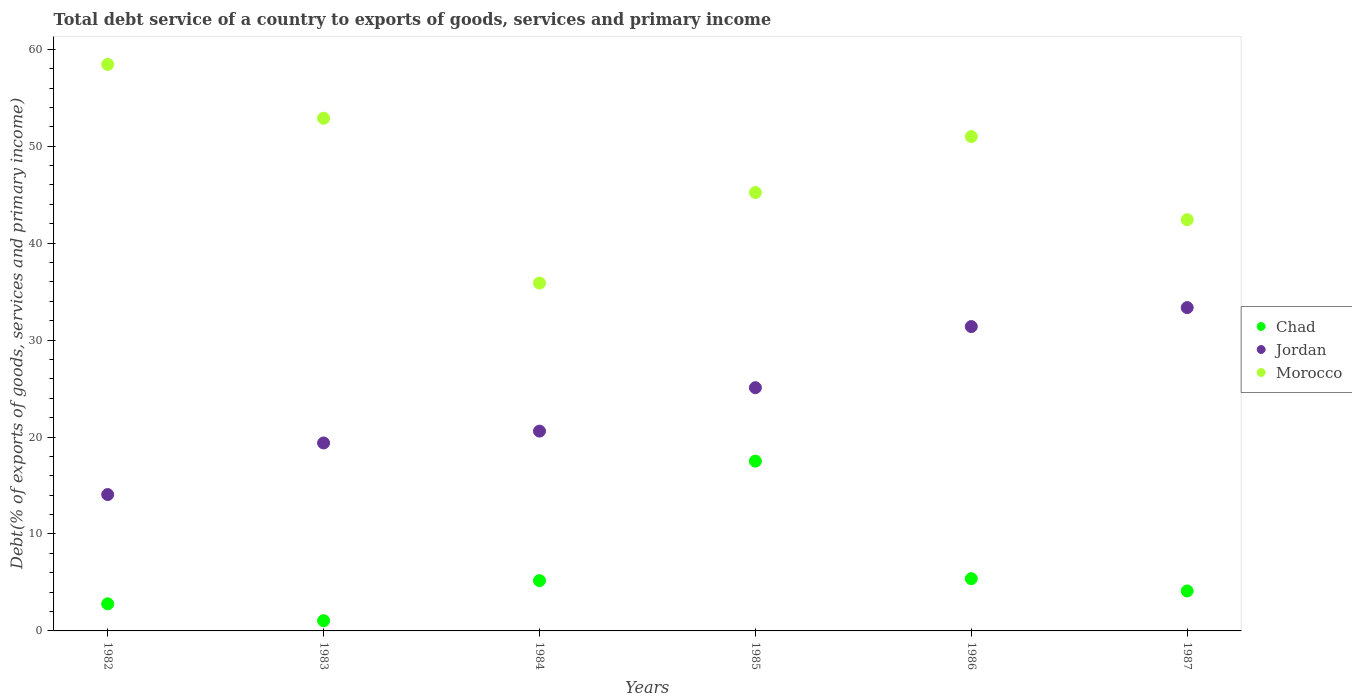How many different coloured dotlines are there?
Your answer should be very brief. 3. What is the total debt service in Morocco in 1983?
Your answer should be very brief. 52.88. Across all years, what is the maximum total debt service in Jordan?
Ensure brevity in your answer.  33.35. Across all years, what is the minimum total debt service in Jordan?
Ensure brevity in your answer.  14.07. What is the total total debt service in Jordan in the graph?
Your answer should be very brief. 143.9. What is the difference between the total debt service in Morocco in 1982 and that in 1987?
Offer a terse response. 16.02. What is the difference between the total debt service in Chad in 1984 and the total debt service in Morocco in 1982?
Offer a very short reply. -53.25. What is the average total debt service in Morocco per year?
Provide a succinct answer. 47.64. In the year 1987, what is the difference between the total debt service in Morocco and total debt service in Chad?
Keep it short and to the point. 38.3. In how many years, is the total debt service in Jordan greater than 26 %?
Give a very brief answer. 2. What is the ratio of the total debt service in Chad in 1982 to that in 1986?
Your answer should be very brief. 0.52. What is the difference between the highest and the second highest total debt service in Jordan?
Make the answer very short. 1.96. What is the difference between the highest and the lowest total debt service in Chad?
Your answer should be very brief. 16.46. In how many years, is the total debt service in Morocco greater than the average total debt service in Morocco taken over all years?
Provide a short and direct response. 3. Is the sum of the total debt service in Jordan in 1983 and 1987 greater than the maximum total debt service in Chad across all years?
Your answer should be compact. Yes. Is it the case that in every year, the sum of the total debt service in Morocco and total debt service in Jordan  is greater than the total debt service in Chad?
Give a very brief answer. Yes. Does the total debt service in Morocco monotonically increase over the years?
Give a very brief answer. No. Are the values on the major ticks of Y-axis written in scientific E-notation?
Offer a terse response. No. Does the graph contain any zero values?
Make the answer very short. No. Where does the legend appear in the graph?
Keep it short and to the point. Center right. How many legend labels are there?
Offer a terse response. 3. What is the title of the graph?
Your answer should be compact. Total debt service of a country to exports of goods, services and primary income. What is the label or title of the Y-axis?
Provide a short and direct response. Debt(% of exports of goods, services and primary income). What is the Debt(% of exports of goods, services and primary income) in Chad in 1982?
Your response must be concise. 2.8. What is the Debt(% of exports of goods, services and primary income) of Jordan in 1982?
Provide a short and direct response. 14.07. What is the Debt(% of exports of goods, services and primary income) of Morocco in 1982?
Offer a terse response. 58.44. What is the Debt(% of exports of goods, services and primary income) of Chad in 1983?
Your answer should be compact. 1.05. What is the Debt(% of exports of goods, services and primary income) in Jordan in 1983?
Provide a short and direct response. 19.39. What is the Debt(% of exports of goods, services and primary income) of Morocco in 1983?
Your response must be concise. 52.88. What is the Debt(% of exports of goods, services and primary income) of Chad in 1984?
Offer a very short reply. 5.19. What is the Debt(% of exports of goods, services and primary income) in Jordan in 1984?
Give a very brief answer. 20.61. What is the Debt(% of exports of goods, services and primary income) in Morocco in 1984?
Your response must be concise. 35.88. What is the Debt(% of exports of goods, services and primary income) of Chad in 1985?
Keep it short and to the point. 17.52. What is the Debt(% of exports of goods, services and primary income) in Jordan in 1985?
Your answer should be very brief. 25.09. What is the Debt(% of exports of goods, services and primary income) of Morocco in 1985?
Keep it short and to the point. 45.22. What is the Debt(% of exports of goods, services and primary income) in Chad in 1986?
Your response must be concise. 5.39. What is the Debt(% of exports of goods, services and primary income) of Jordan in 1986?
Your answer should be compact. 31.39. What is the Debt(% of exports of goods, services and primary income) in Morocco in 1986?
Offer a very short reply. 51. What is the Debt(% of exports of goods, services and primary income) in Chad in 1987?
Your answer should be very brief. 4.12. What is the Debt(% of exports of goods, services and primary income) in Jordan in 1987?
Keep it short and to the point. 33.35. What is the Debt(% of exports of goods, services and primary income) in Morocco in 1987?
Keep it short and to the point. 42.42. Across all years, what is the maximum Debt(% of exports of goods, services and primary income) of Chad?
Ensure brevity in your answer.  17.52. Across all years, what is the maximum Debt(% of exports of goods, services and primary income) in Jordan?
Your answer should be very brief. 33.35. Across all years, what is the maximum Debt(% of exports of goods, services and primary income) of Morocco?
Make the answer very short. 58.44. Across all years, what is the minimum Debt(% of exports of goods, services and primary income) of Chad?
Your answer should be compact. 1.05. Across all years, what is the minimum Debt(% of exports of goods, services and primary income) of Jordan?
Provide a succinct answer. 14.07. Across all years, what is the minimum Debt(% of exports of goods, services and primary income) of Morocco?
Ensure brevity in your answer.  35.88. What is the total Debt(% of exports of goods, services and primary income) in Chad in the graph?
Provide a short and direct response. 36.06. What is the total Debt(% of exports of goods, services and primary income) in Jordan in the graph?
Ensure brevity in your answer.  143.9. What is the total Debt(% of exports of goods, services and primary income) of Morocco in the graph?
Give a very brief answer. 285.85. What is the difference between the Debt(% of exports of goods, services and primary income) of Chad in 1982 and that in 1983?
Provide a short and direct response. 1.74. What is the difference between the Debt(% of exports of goods, services and primary income) in Jordan in 1982 and that in 1983?
Provide a succinct answer. -5.32. What is the difference between the Debt(% of exports of goods, services and primary income) of Morocco in 1982 and that in 1983?
Your answer should be very brief. 5.55. What is the difference between the Debt(% of exports of goods, services and primary income) of Chad in 1982 and that in 1984?
Make the answer very short. -2.39. What is the difference between the Debt(% of exports of goods, services and primary income) in Jordan in 1982 and that in 1984?
Give a very brief answer. -6.54. What is the difference between the Debt(% of exports of goods, services and primary income) in Morocco in 1982 and that in 1984?
Your answer should be compact. 22.56. What is the difference between the Debt(% of exports of goods, services and primary income) in Chad in 1982 and that in 1985?
Keep it short and to the point. -14.72. What is the difference between the Debt(% of exports of goods, services and primary income) in Jordan in 1982 and that in 1985?
Your answer should be very brief. -11.03. What is the difference between the Debt(% of exports of goods, services and primary income) of Morocco in 1982 and that in 1985?
Give a very brief answer. 13.22. What is the difference between the Debt(% of exports of goods, services and primary income) in Chad in 1982 and that in 1986?
Offer a terse response. -2.59. What is the difference between the Debt(% of exports of goods, services and primary income) in Jordan in 1982 and that in 1986?
Offer a very short reply. -17.33. What is the difference between the Debt(% of exports of goods, services and primary income) of Morocco in 1982 and that in 1986?
Offer a very short reply. 7.44. What is the difference between the Debt(% of exports of goods, services and primary income) in Chad in 1982 and that in 1987?
Your response must be concise. -1.32. What is the difference between the Debt(% of exports of goods, services and primary income) of Jordan in 1982 and that in 1987?
Offer a very short reply. -19.29. What is the difference between the Debt(% of exports of goods, services and primary income) in Morocco in 1982 and that in 1987?
Provide a short and direct response. 16.02. What is the difference between the Debt(% of exports of goods, services and primary income) of Chad in 1983 and that in 1984?
Ensure brevity in your answer.  -4.13. What is the difference between the Debt(% of exports of goods, services and primary income) in Jordan in 1983 and that in 1984?
Offer a very short reply. -1.22. What is the difference between the Debt(% of exports of goods, services and primary income) of Morocco in 1983 and that in 1984?
Give a very brief answer. 17. What is the difference between the Debt(% of exports of goods, services and primary income) of Chad in 1983 and that in 1985?
Your answer should be very brief. -16.46. What is the difference between the Debt(% of exports of goods, services and primary income) in Jordan in 1983 and that in 1985?
Offer a very short reply. -5.7. What is the difference between the Debt(% of exports of goods, services and primary income) in Morocco in 1983 and that in 1985?
Ensure brevity in your answer.  7.66. What is the difference between the Debt(% of exports of goods, services and primary income) of Chad in 1983 and that in 1986?
Ensure brevity in your answer.  -4.33. What is the difference between the Debt(% of exports of goods, services and primary income) of Jordan in 1983 and that in 1986?
Your answer should be compact. -12.01. What is the difference between the Debt(% of exports of goods, services and primary income) of Morocco in 1983 and that in 1986?
Provide a succinct answer. 1.89. What is the difference between the Debt(% of exports of goods, services and primary income) of Chad in 1983 and that in 1987?
Your answer should be very brief. -3.06. What is the difference between the Debt(% of exports of goods, services and primary income) of Jordan in 1983 and that in 1987?
Your response must be concise. -13.96. What is the difference between the Debt(% of exports of goods, services and primary income) in Morocco in 1983 and that in 1987?
Your response must be concise. 10.46. What is the difference between the Debt(% of exports of goods, services and primary income) in Chad in 1984 and that in 1985?
Your response must be concise. -12.33. What is the difference between the Debt(% of exports of goods, services and primary income) of Jordan in 1984 and that in 1985?
Your answer should be compact. -4.48. What is the difference between the Debt(% of exports of goods, services and primary income) in Morocco in 1984 and that in 1985?
Your answer should be compact. -9.34. What is the difference between the Debt(% of exports of goods, services and primary income) of Chad in 1984 and that in 1986?
Keep it short and to the point. -0.2. What is the difference between the Debt(% of exports of goods, services and primary income) of Jordan in 1984 and that in 1986?
Give a very brief answer. -10.78. What is the difference between the Debt(% of exports of goods, services and primary income) in Morocco in 1984 and that in 1986?
Your answer should be very brief. -15.11. What is the difference between the Debt(% of exports of goods, services and primary income) of Chad in 1984 and that in 1987?
Provide a succinct answer. 1.07. What is the difference between the Debt(% of exports of goods, services and primary income) of Jordan in 1984 and that in 1987?
Your response must be concise. -12.74. What is the difference between the Debt(% of exports of goods, services and primary income) of Morocco in 1984 and that in 1987?
Make the answer very short. -6.54. What is the difference between the Debt(% of exports of goods, services and primary income) of Chad in 1985 and that in 1986?
Your response must be concise. 12.13. What is the difference between the Debt(% of exports of goods, services and primary income) of Jordan in 1985 and that in 1986?
Keep it short and to the point. -6.3. What is the difference between the Debt(% of exports of goods, services and primary income) of Morocco in 1985 and that in 1986?
Your answer should be very brief. -5.77. What is the difference between the Debt(% of exports of goods, services and primary income) in Chad in 1985 and that in 1987?
Offer a very short reply. 13.4. What is the difference between the Debt(% of exports of goods, services and primary income) of Jordan in 1985 and that in 1987?
Provide a short and direct response. -8.26. What is the difference between the Debt(% of exports of goods, services and primary income) of Morocco in 1985 and that in 1987?
Provide a succinct answer. 2.8. What is the difference between the Debt(% of exports of goods, services and primary income) of Chad in 1986 and that in 1987?
Provide a short and direct response. 1.27. What is the difference between the Debt(% of exports of goods, services and primary income) in Jordan in 1986 and that in 1987?
Make the answer very short. -1.96. What is the difference between the Debt(% of exports of goods, services and primary income) of Morocco in 1986 and that in 1987?
Your answer should be very brief. 8.57. What is the difference between the Debt(% of exports of goods, services and primary income) in Chad in 1982 and the Debt(% of exports of goods, services and primary income) in Jordan in 1983?
Provide a succinct answer. -16.59. What is the difference between the Debt(% of exports of goods, services and primary income) of Chad in 1982 and the Debt(% of exports of goods, services and primary income) of Morocco in 1983?
Provide a succinct answer. -50.09. What is the difference between the Debt(% of exports of goods, services and primary income) in Jordan in 1982 and the Debt(% of exports of goods, services and primary income) in Morocco in 1983?
Your answer should be very brief. -38.82. What is the difference between the Debt(% of exports of goods, services and primary income) in Chad in 1982 and the Debt(% of exports of goods, services and primary income) in Jordan in 1984?
Offer a very short reply. -17.81. What is the difference between the Debt(% of exports of goods, services and primary income) of Chad in 1982 and the Debt(% of exports of goods, services and primary income) of Morocco in 1984?
Give a very brief answer. -33.09. What is the difference between the Debt(% of exports of goods, services and primary income) in Jordan in 1982 and the Debt(% of exports of goods, services and primary income) in Morocco in 1984?
Make the answer very short. -21.82. What is the difference between the Debt(% of exports of goods, services and primary income) in Chad in 1982 and the Debt(% of exports of goods, services and primary income) in Jordan in 1985?
Give a very brief answer. -22.29. What is the difference between the Debt(% of exports of goods, services and primary income) of Chad in 1982 and the Debt(% of exports of goods, services and primary income) of Morocco in 1985?
Your response must be concise. -42.43. What is the difference between the Debt(% of exports of goods, services and primary income) of Jordan in 1982 and the Debt(% of exports of goods, services and primary income) of Morocco in 1985?
Your response must be concise. -31.16. What is the difference between the Debt(% of exports of goods, services and primary income) in Chad in 1982 and the Debt(% of exports of goods, services and primary income) in Jordan in 1986?
Keep it short and to the point. -28.6. What is the difference between the Debt(% of exports of goods, services and primary income) of Chad in 1982 and the Debt(% of exports of goods, services and primary income) of Morocco in 1986?
Keep it short and to the point. -48.2. What is the difference between the Debt(% of exports of goods, services and primary income) in Jordan in 1982 and the Debt(% of exports of goods, services and primary income) in Morocco in 1986?
Keep it short and to the point. -36.93. What is the difference between the Debt(% of exports of goods, services and primary income) of Chad in 1982 and the Debt(% of exports of goods, services and primary income) of Jordan in 1987?
Offer a very short reply. -30.55. What is the difference between the Debt(% of exports of goods, services and primary income) in Chad in 1982 and the Debt(% of exports of goods, services and primary income) in Morocco in 1987?
Your answer should be very brief. -39.62. What is the difference between the Debt(% of exports of goods, services and primary income) in Jordan in 1982 and the Debt(% of exports of goods, services and primary income) in Morocco in 1987?
Your answer should be compact. -28.36. What is the difference between the Debt(% of exports of goods, services and primary income) of Chad in 1983 and the Debt(% of exports of goods, services and primary income) of Jordan in 1984?
Provide a succinct answer. -19.55. What is the difference between the Debt(% of exports of goods, services and primary income) of Chad in 1983 and the Debt(% of exports of goods, services and primary income) of Morocco in 1984?
Offer a very short reply. -34.83. What is the difference between the Debt(% of exports of goods, services and primary income) of Jordan in 1983 and the Debt(% of exports of goods, services and primary income) of Morocco in 1984?
Ensure brevity in your answer.  -16.5. What is the difference between the Debt(% of exports of goods, services and primary income) in Chad in 1983 and the Debt(% of exports of goods, services and primary income) in Jordan in 1985?
Ensure brevity in your answer.  -24.04. What is the difference between the Debt(% of exports of goods, services and primary income) in Chad in 1983 and the Debt(% of exports of goods, services and primary income) in Morocco in 1985?
Your response must be concise. -44.17. What is the difference between the Debt(% of exports of goods, services and primary income) of Jordan in 1983 and the Debt(% of exports of goods, services and primary income) of Morocco in 1985?
Your answer should be very brief. -25.84. What is the difference between the Debt(% of exports of goods, services and primary income) in Chad in 1983 and the Debt(% of exports of goods, services and primary income) in Jordan in 1986?
Your response must be concise. -30.34. What is the difference between the Debt(% of exports of goods, services and primary income) of Chad in 1983 and the Debt(% of exports of goods, services and primary income) of Morocco in 1986?
Ensure brevity in your answer.  -49.94. What is the difference between the Debt(% of exports of goods, services and primary income) of Jordan in 1983 and the Debt(% of exports of goods, services and primary income) of Morocco in 1986?
Your answer should be very brief. -31.61. What is the difference between the Debt(% of exports of goods, services and primary income) of Chad in 1983 and the Debt(% of exports of goods, services and primary income) of Jordan in 1987?
Ensure brevity in your answer.  -32.3. What is the difference between the Debt(% of exports of goods, services and primary income) of Chad in 1983 and the Debt(% of exports of goods, services and primary income) of Morocco in 1987?
Offer a very short reply. -41.37. What is the difference between the Debt(% of exports of goods, services and primary income) of Jordan in 1983 and the Debt(% of exports of goods, services and primary income) of Morocco in 1987?
Give a very brief answer. -23.03. What is the difference between the Debt(% of exports of goods, services and primary income) of Chad in 1984 and the Debt(% of exports of goods, services and primary income) of Jordan in 1985?
Ensure brevity in your answer.  -19.9. What is the difference between the Debt(% of exports of goods, services and primary income) of Chad in 1984 and the Debt(% of exports of goods, services and primary income) of Morocco in 1985?
Offer a very short reply. -40.04. What is the difference between the Debt(% of exports of goods, services and primary income) in Jordan in 1984 and the Debt(% of exports of goods, services and primary income) in Morocco in 1985?
Make the answer very short. -24.61. What is the difference between the Debt(% of exports of goods, services and primary income) in Chad in 1984 and the Debt(% of exports of goods, services and primary income) in Jordan in 1986?
Offer a terse response. -26.21. What is the difference between the Debt(% of exports of goods, services and primary income) of Chad in 1984 and the Debt(% of exports of goods, services and primary income) of Morocco in 1986?
Offer a terse response. -45.81. What is the difference between the Debt(% of exports of goods, services and primary income) in Jordan in 1984 and the Debt(% of exports of goods, services and primary income) in Morocco in 1986?
Keep it short and to the point. -30.39. What is the difference between the Debt(% of exports of goods, services and primary income) of Chad in 1984 and the Debt(% of exports of goods, services and primary income) of Jordan in 1987?
Make the answer very short. -28.16. What is the difference between the Debt(% of exports of goods, services and primary income) of Chad in 1984 and the Debt(% of exports of goods, services and primary income) of Morocco in 1987?
Provide a short and direct response. -37.23. What is the difference between the Debt(% of exports of goods, services and primary income) in Jordan in 1984 and the Debt(% of exports of goods, services and primary income) in Morocco in 1987?
Offer a very short reply. -21.81. What is the difference between the Debt(% of exports of goods, services and primary income) in Chad in 1985 and the Debt(% of exports of goods, services and primary income) in Jordan in 1986?
Your response must be concise. -13.88. What is the difference between the Debt(% of exports of goods, services and primary income) in Chad in 1985 and the Debt(% of exports of goods, services and primary income) in Morocco in 1986?
Offer a very short reply. -33.48. What is the difference between the Debt(% of exports of goods, services and primary income) of Jordan in 1985 and the Debt(% of exports of goods, services and primary income) of Morocco in 1986?
Keep it short and to the point. -25.9. What is the difference between the Debt(% of exports of goods, services and primary income) in Chad in 1985 and the Debt(% of exports of goods, services and primary income) in Jordan in 1987?
Your answer should be very brief. -15.84. What is the difference between the Debt(% of exports of goods, services and primary income) in Chad in 1985 and the Debt(% of exports of goods, services and primary income) in Morocco in 1987?
Provide a short and direct response. -24.91. What is the difference between the Debt(% of exports of goods, services and primary income) in Jordan in 1985 and the Debt(% of exports of goods, services and primary income) in Morocco in 1987?
Give a very brief answer. -17.33. What is the difference between the Debt(% of exports of goods, services and primary income) of Chad in 1986 and the Debt(% of exports of goods, services and primary income) of Jordan in 1987?
Ensure brevity in your answer.  -27.96. What is the difference between the Debt(% of exports of goods, services and primary income) of Chad in 1986 and the Debt(% of exports of goods, services and primary income) of Morocco in 1987?
Your answer should be compact. -37.03. What is the difference between the Debt(% of exports of goods, services and primary income) in Jordan in 1986 and the Debt(% of exports of goods, services and primary income) in Morocco in 1987?
Provide a short and direct response. -11.03. What is the average Debt(% of exports of goods, services and primary income) in Chad per year?
Provide a short and direct response. 6.01. What is the average Debt(% of exports of goods, services and primary income) of Jordan per year?
Give a very brief answer. 23.98. What is the average Debt(% of exports of goods, services and primary income) of Morocco per year?
Your answer should be very brief. 47.64. In the year 1982, what is the difference between the Debt(% of exports of goods, services and primary income) in Chad and Debt(% of exports of goods, services and primary income) in Jordan?
Your answer should be very brief. -11.27. In the year 1982, what is the difference between the Debt(% of exports of goods, services and primary income) in Chad and Debt(% of exports of goods, services and primary income) in Morocco?
Your answer should be very brief. -55.64. In the year 1982, what is the difference between the Debt(% of exports of goods, services and primary income) of Jordan and Debt(% of exports of goods, services and primary income) of Morocco?
Your answer should be compact. -44.37. In the year 1983, what is the difference between the Debt(% of exports of goods, services and primary income) of Chad and Debt(% of exports of goods, services and primary income) of Jordan?
Your answer should be compact. -18.33. In the year 1983, what is the difference between the Debt(% of exports of goods, services and primary income) in Chad and Debt(% of exports of goods, services and primary income) in Morocco?
Make the answer very short. -51.83. In the year 1983, what is the difference between the Debt(% of exports of goods, services and primary income) of Jordan and Debt(% of exports of goods, services and primary income) of Morocco?
Your answer should be very brief. -33.5. In the year 1984, what is the difference between the Debt(% of exports of goods, services and primary income) in Chad and Debt(% of exports of goods, services and primary income) in Jordan?
Keep it short and to the point. -15.42. In the year 1984, what is the difference between the Debt(% of exports of goods, services and primary income) in Chad and Debt(% of exports of goods, services and primary income) in Morocco?
Make the answer very short. -30.7. In the year 1984, what is the difference between the Debt(% of exports of goods, services and primary income) of Jordan and Debt(% of exports of goods, services and primary income) of Morocco?
Provide a short and direct response. -15.27. In the year 1985, what is the difference between the Debt(% of exports of goods, services and primary income) of Chad and Debt(% of exports of goods, services and primary income) of Jordan?
Make the answer very short. -7.58. In the year 1985, what is the difference between the Debt(% of exports of goods, services and primary income) in Chad and Debt(% of exports of goods, services and primary income) in Morocco?
Offer a very short reply. -27.71. In the year 1985, what is the difference between the Debt(% of exports of goods, services and primary income) in Jordan and Debt(% of exports of goods, services and primary income) in Morocco?
Offer a terse response. -20.13. In the year 1986, what is the difference between the Debt(% of exports of goods, services and primary income) in Chad and Debt(% of exports of goods, services and primary income) in Jordan?
Your answer should be compact. -26.01. In the year 1986, what is the difference between the Debt(% of exports of goods, services and primary income) of Chad and Debt(% of exports of goods, services and primary income) of Morocco?
Your answer should be very brief. -45.61. In the year 1986, what is the difference between the Debt(% of exports of goods, services and primary income) in Jordan and Debt(% of exports of goods, services and primary income) in Morocco?
Make the answer very short. -19.6. In the year 1987, what is the difference between the Debt(% of exports of goods, services and primary income) of Chad and Debt(% of exports of goods, services and primary income) of Jordan?
Ensure brevity in your answer.  -29.23. In the year 1987, what is the difference between the Debt(% of exports of goods, services and primary income) of Chad and Debt(% of exports of goods, services and primary income) of Morocco?
Keep it short and to the point. -38.3. In the year 1987, what is the difference between the Debt(% of exports of goods, services and primary income) in Jordan and Debt(% of exports of goods, services and primary income) in Morocco?
Offer a terse response. -9.07. What is the ratio of the Debt(% of exports of goods, services and primary income) in Chad in 1982 to that in 1983?
Your answer should be very brief. 2.65. What is the ratio of the Debt(% of exports of goods, services and primary income) of Jordan in 1982 to that in 1983?
Your answer should be very brief. 0.73. What is the ratio of the Debt(% of exports of goods, services and primary income) in Morocco in 1982 to that in 1983?
Keep it short and to the point. 1.1. What is the ratio of the Debt(% of exports of goods, services and primary income) in Chad in 1982 to that in 1984?
Give a very brief answer. 0.54. What is the ratio of the Debt(% of exports of goods, services and primary income) in Jordan in 1982 to that in 1984?
Ensure brevity in your answer.  0.68. What is the ratio of the Debt(% of exports of goods, services and primary income) in Morocco in 1982 to that in 1984?
Offer a very short reply. 1.63. What is the ratio of the Debt(% of exports of goods, services and primary income) in Chad in 1982 to that in 1985?
Provide a short and direct response. 0.16. What is the ratio of the Debt(% of exports of goods, services and primary income) in Jordan in 1982 to that in 1985?
Provide a succinct answer. 0.56. What is the ratio of the Debt(% of exports of goods, services and primary income) of Morocco in 1982 to that in 1985?
Keep it short and to the point. 1.29. What is the ratio of the Debt(% of exports of goods, services and primary income) in Chad in 1982 to that in 1986?
Your answer should be very brief. 0.52. What is the ratio of the Debt(% of exports of goods, services and primary income) of Jordan in 1982 to that in 1986?
Ensure brevity in your answer.  0.45. What is the ratio of the Debt(% of exports of goods, services and primary income) in Morocco in 1982 to that in 1986?
Offer a terse response. 1.15. What is the ratio of the Debt(% of exports of goods, services and primary income) in Chad in 1982 to that in 1987?
Provide a succinct answer. 0.68. What is the ratio of the Debt(% of exports of goods, services and primary income) in Jordan in 1982 to that in 1987?
Keep it short and to the point. 0.42. What is the ratio of the Debt(% of exports of goods, services and primary income) of Morocco in 1982 to that in 1987?
Your answer should be very brief. 1.38. What is the ratio of the Debt(% of exports of goods, services and primary income) in Chad in 1983 to that in 1984?
Make the answer very short. 0.2. What is the ratio of the Debt(% of exports of goods, services and primary income) in Jordan in 1983 to that in 1984?
Ensure brevity in your answer.  0.94. What is the ratio of the Debt(% of exports of goods, services and primary income) of Morocco in 1983 to that in 1984?
Provide a succinct answer. 1.47. What is the ratio of the Debt(% of exports of goods, services and primary income) in Chad in 1983 to that in 1985?
Your response must be concise. 0.06. What is the ratio of the Debt(% of exports of goods, services and primary income) of Jordan in 1983 to that in 1985?
Give a very brief answer. 0.77. What is the ratio of the Debt(% of exports of goods, services and primary income) of Morocco in 1983 to that in 1985?
Your answer should be very brief. 1.17. What is the ratio of the Debt(% of exports of goods, services and primary income) of Chad in 1983 to that in 1986?
Make the answer very short. 0.2. What is the ratio of the Debt(% of exports of goods, services and primary income) in Jordan in 1983 to that in 1986?
Offer a very short reply. 0.62. What is the ratio of the Debt(% of exports of goods, services and primary income) of Morocco in 1983 to that in 1986?
Provide a succinct answer. 1.04. What is the ratio of the Debt(% of exports of goods, services and primary income) in Chad in 1983 to that in 1987?
Your response must be concise. 0.26. What is the ratio of the Debt(% of exports of goods, services and primary income) in Jordan in 1983 to that in 1987?
Offer a very short reply. 0.58. What is the ratio of the Debt(% of exports of goods, services and primary income) of Morocco in 1983 to that in 1987?
Ensure brevity in your answer.  1.25. What is the ratio of the Debt(% of exports of goods, services and primary income) in Chad in 1984 to that in 1985?
Offer a very short reply. 0.3. What is the ratio of the Debt(% of exports of goods, services and primary income) of Jordan in 1984 to that in 1985?
Your answer should be compact. 0.82. What is the ratio of the Debt(% of exports of goods, services and primary income) of Morocco in 1984 to that in 1985?
Offer a terse response. 0.79. What is the ratio of the Debt(% of exports of goods, services and primary income) in Chad in 1984 to that in 1986?
Provide a short and direct response. 0.96. What is the ratio of the Debt(% of exports of goods, services and primary income) in Jordan in 1984 to that in 1986?
Your response must be concise. 0.66. What is the ratio of the Debt(% of exports of goods, services and primary income) of Morocco in 1984 to that in 1986?
Give a very brief answer. 0.7. What is the ratio of the Debt(% of exports of goods, services and primary income) of Chad in 1984 to that in 1987?
Provide a succinct answer. 1.26. What is the ratio of the Debt(% of exports of goods, services and primary income) of Jordan in 1984 to that in 1987?
Provide a succinct answer. 0.62. What is the ratio of the Debt(% of exports of goods, services and primary income) of Morocco in 1984 to that in 1987?
Keep it short and to the point. 0.85. What is the ratio of the Debt(% of exports of goods, services and primary income) in Chad in 1985 to that in 1986?
Your response must be concise. 3.25. What is the ratio of the Debt(% of exports of goods, services and primary income) in Jordan in 1985 to that in 1986?
Your response must be concise. 0.8. What is the ratio of the Debt(% of exports of goods, services and primary income) of Morocco in 1985 to that in 1986?
Offer a very short reply. 0.89. What is the ratio of the Debt(% of exports of goods, services and primary income) of Chad in 1985 to that in 1987?
Ensure brevity in your answer.  4.25. What is the ratio of the Debt(% of exports of goods, services and primary income) of Jordan in 1985 to that in 1987?
Your response must be concise. 0.75. What is the ratio of the Debt(% of exports of goods, services and primary income) in Morocco in 1985 to that in 1987?
Offer a very short reply. 1.07. What is the ratio of the Debt(% of exports of goods, services and primary income) in Chad in 1986 to that in 1987?
Your answer should be compact. 1.31. What is the ratio of the Debt(% of exports of goods, services and primary income) of Jordan in 1986 to that in 1987?
Your answer should be compact. 0.94. What is the ratio of the Debt(% of exports of goods, services and primary income) in Morocco in 1986 to that in 1987?
Your answer should be compact. 1.2. What is the difference between the highest and the second highest Debt(% of exports of goods, services and primary income) in Chad?
Give a very brief answer. 12.13. What is the difference between the highest and the second highest Debt(% of exports of goods, services and primary income) of Jordan?
Your answer should be compact. 1.96. What is the difference between the highest and the second highest Debt(% of exports of goods, services and primary income) in Morocco?
Provide a succinct answer. 5.55. What is the difference between the highest and the lowest Debt(% of exports of goods, services and primary income) in Chad?
Keep it short and to the point. 16.46. What is the difference between the highest and the lowest Debt(% of exports of goods, services and primary income) in Jordan?
Make the answer very short. 19.29. What is the difference between the highest and the lowest Debt(% of exports of goods, services and primary income) of Morocco?
Your response must be concise. 22.56. 